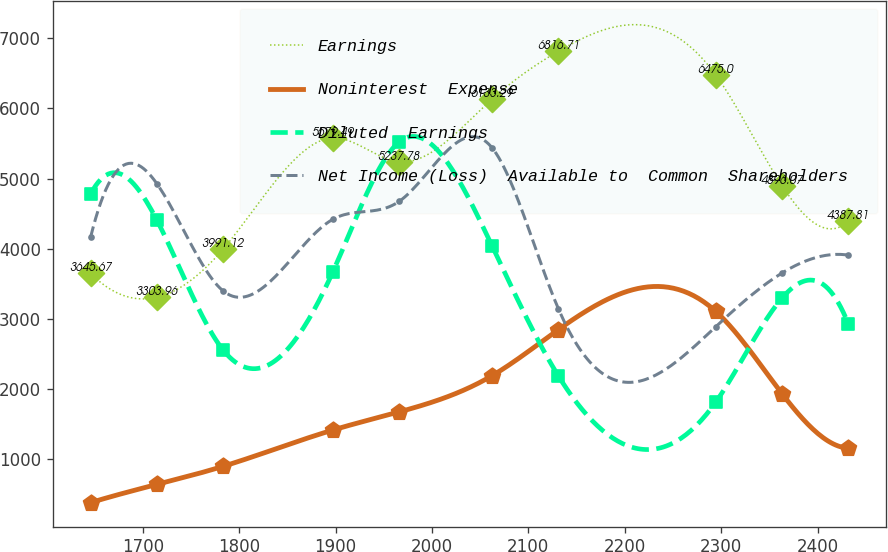Convert chart. <chart><loc_0><loc_0><loc_500><loc_500><line_chart><ecel><fcel>Earnings<fcel>Noninterest  Expense<fcel>Diluted  Earnings<fcel>Net Income (Loss)  Available to  Common  Shareholders<nl><fcel>1645.9<fcel>3645.67<fcel>372.85<fcel>4778.42<fcel>4161.63<nl><fcel>1714.61<fcel>3303.96<fcel>631.78<fcel>4407.39<fcel>4927.11<nl><fcel>1783.32<fcel>3991.12<fcel>890.71<fcel>2552.24<fcel>3396.15<nl><fcel>1897.12<fcel>5579.49<fcel>1408.57<fcel>3665.33<fcel>4416.79<nl><fcel>1965.83<fcel>5237.78<fcel>1667.5<fcel>5520.47<fcel>4671.95<nl><fcel>2062.41<fcel>6133.29<fcel>2185.36<fcel>4036.36<fcel>5437.42<nl><fcel>2131.12<fcel>6816.71<fcel>2842.49<fcel>2181.21<fcel>3140.99<nl><fcel>2294.51<fcel>6475<fcel>3101.42<fcel>1810.18<fcel>2885.83<nl><fcel>2363.22<fcel>4896.07<fcel>1926.43<fcel>3294.3<fcel>3651.31<nl><fcel>2431.93<fcel>4387.81<fcel>1149.64<fcel>2923.27<fcel>3906.47<nl></chart> 